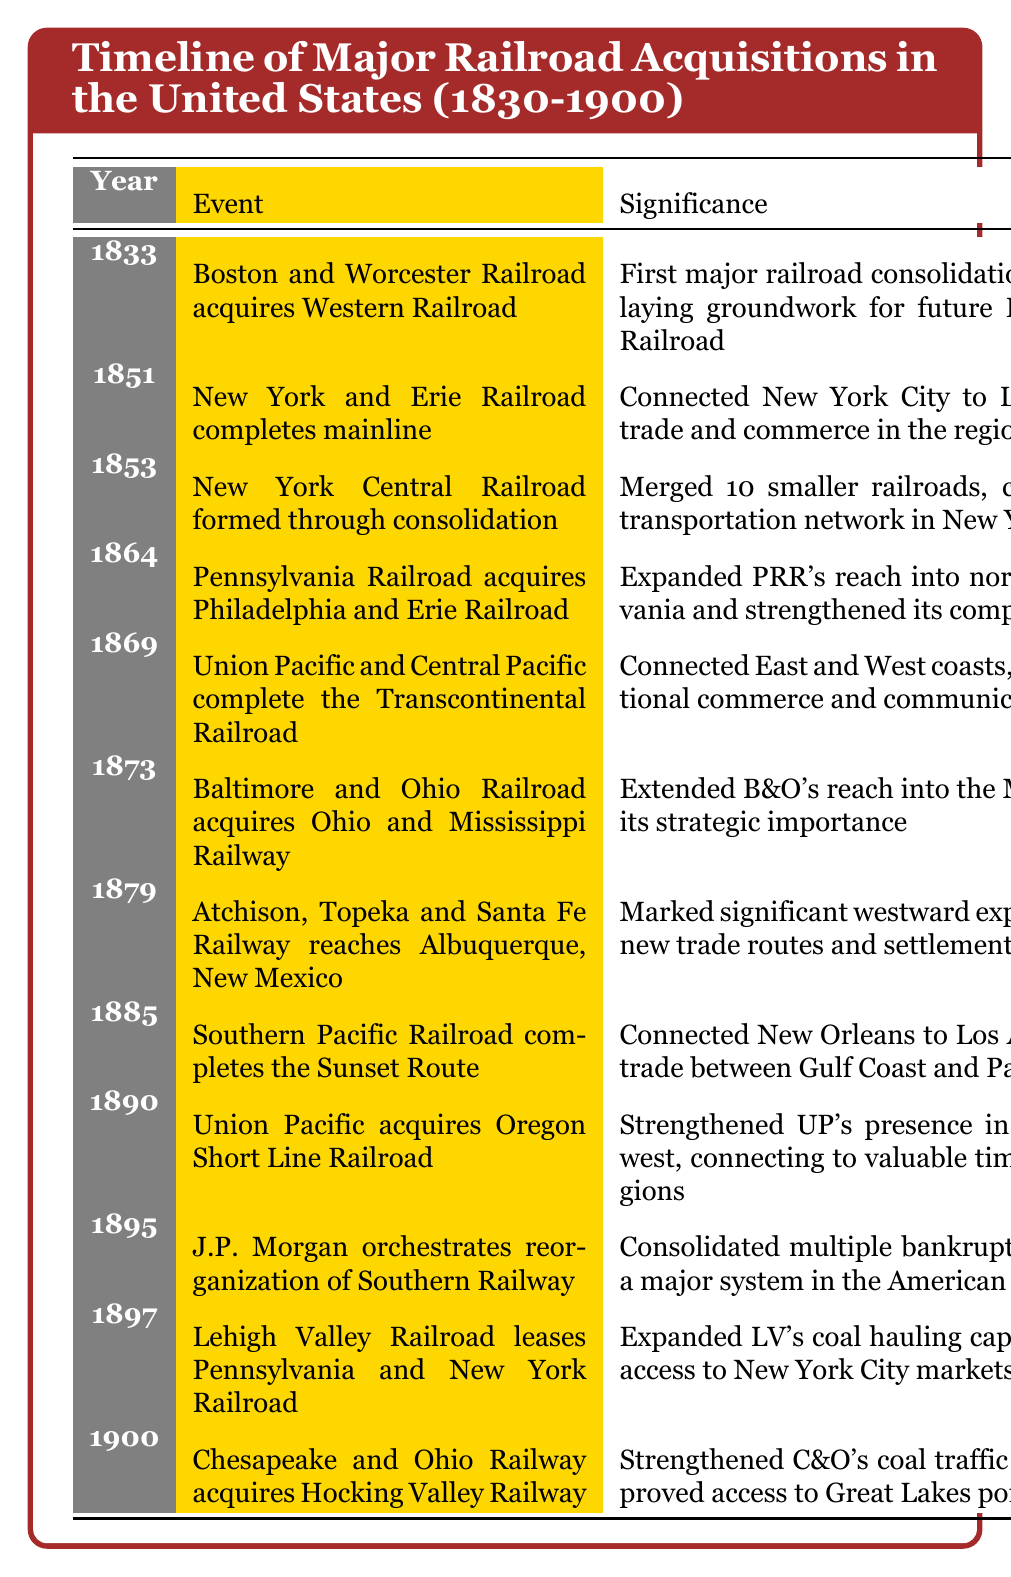What event occurred in 1851? The event listed for 1851 in the table is "New York and Erie Railroad completes mainline". There's a direct reference to the year in the event column.
Answer: New York and Erie Railroad completes mainline What was the significance of the 1869 acquisition of the Transcontinental Railroad? The significance of the 1869 event explains its historical context: it connected the East and West coasts, revolutionizing national commerce and communication. Thus, this acquisition marked a major turning point in American infrastructure.
Answer: It revolutionized national commerce and communication Which railroad was acquired by the Pennsylvania Railroad in 1864? The table indicates that the Pennsylvania Railroad acquired the Philadelphia and Erie Railroad in 1864. This information can be found directly in the event column.
Answer: Philadelphia and Erie Railroad How many acquisitions or significant events were related to the Union Pacific Railroad? Looking at the table, there are two events connected to the Union Pacific Railroad: one in 1869 (completion of the Transcontinental Railroad) and another in 1890 (acquisition of the Oregon Short Line Railroad). We simply count these two instances.
Answer: 2 Was there a railroad acquisition that expanded reach into the Midwest in 1873? Yes, according to the event in the table, the Baltimore and Ohio Railroad acquired the Ohio and Mississippi Railway in 1873, indicating an expansion into the Midwest.
Answer: Yes What year saw both the completion of the Transcontinental Railroad and a significant expansion by the Union Pacific Railroad? The table details that both events occurred in 1869. Specifically, the Transcontinental Railroad was completed by Union Pacific and Central Pacific, which aligns with the Union Pacific’s expansion efforts as cited.
Answer: 1869 Which acquisition strengthened the Lehigh Valley Railroad's coal hauling capacity in 1897? The table lists that the Lehigh Valley Railroad leased the Pennsylvania and New York Railroad in 1897, which expanded its coal hauling capacity. Thus, this event strengthens its operations in coal transport.
Answer: Pennsylvania and New York Railroad What impact did the Southern Pacific Railroad's Sunset Route have on trade in 1885? According to the table, the significance of connecting New Orleans to Los Angeles was that it facilitated trade between the Gulf Coast and the Pacific Coast, indicating a major economic impact.
Answer: Facilitated trade between Gulf Coast and Pacific Coast What is the average year of the events listed in the table? To find the average year, we take the sum of all the years: (1833 + 1851 + 1853 + 1864 + 1869 + 1873 + 1879 + 1885 + 1890 + 1895 + 1897 + 1900) = 22,312. There are 12 events total. Therefore, the average is 22,312 / 12 = 1863.
Answer: 1863 